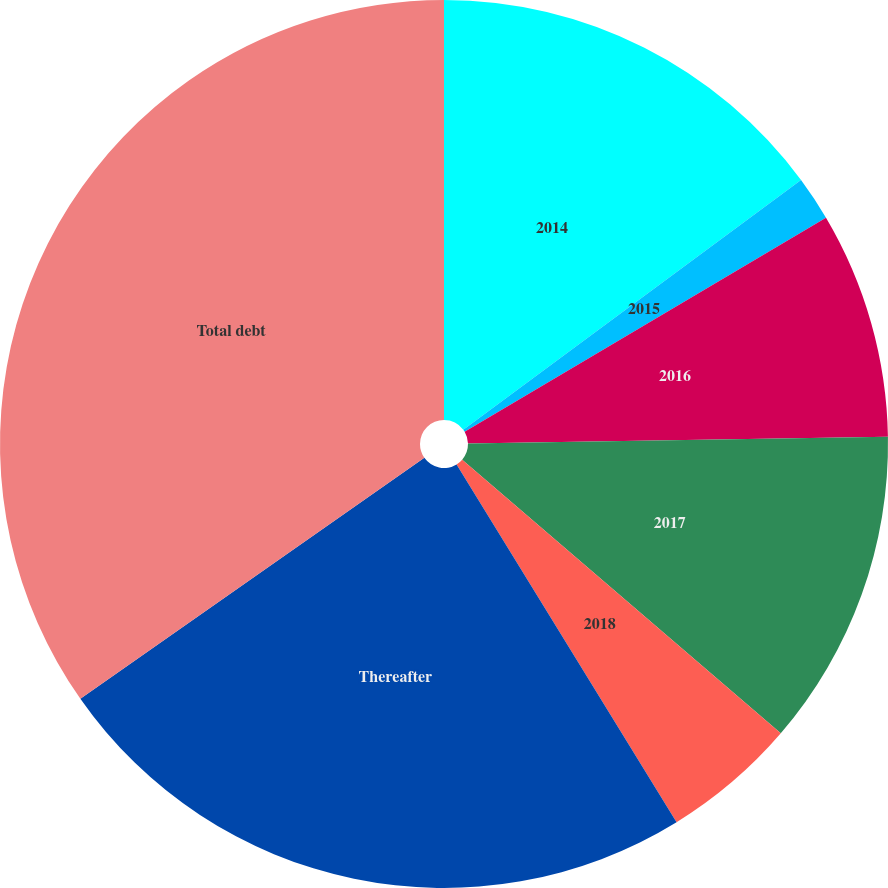<chart> <loc_0><loc_0><loc_500><loc_500><pie_chart><fcel>2014<fcel>2015<fcel>2016<fcel>2017<fcel>2018<fcel>Thereafter<fcel>Total debt<nl><fcel>14.87%<fcel>1.62%<fcel>8.25%<fcel>11.56%<fcel>4.93%<fcel>24.05%<fcel>34.73%<nl></chart> 